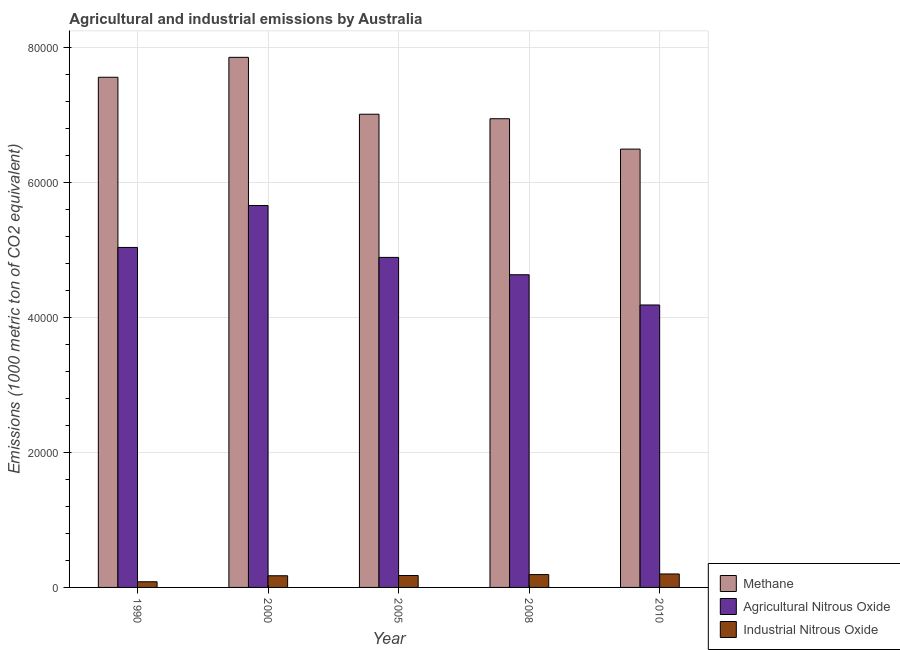How many groups of bars are there?
Ensure brevity in your answer.  5. What is the label of the 1st group of bars from the left?
Ensure brevity in your answer.  1990. What is the amount of methane emissions in 2000?
Make the answer very short. 7.85e+04. Across all years, what is the maximum amount of agricultural nitrous oxide emissions?
Provide a succinct answer. 5.66e+04. Across all years, what is the minimum amount of methane emissions?
Provide a short and direct response. 6.50e+04. What is the total amount of methane emissions in the graph?
Provide a short and direct response. 3.59e+05. What is the difference between the amount of methane emissions in 1990 and that in 2010?
Keep it short and to the point. 1.06e+04. What is the difference between the amount of industrial nitrous oxide emissions in 2005 and the amount of agricultural nitrous oxide emissions in 1990?
Ensure brevity in your answer.  925.7. What is the average amount of industrial nitrous oxide emissions per year?
Offer a very short reply. 1646.6. What is the ratio of the amount of industrial nitrous oxide emissions in 2005 to that in 2010?
Your response must be concise. 0.89. Is the difference between the amount of industrial nitrous oxide emissions in 2008 and 2010 greater than the difference between the amount of methane emissions in 2008 and 2010?
Offer a very short reply. No. What is the difference between the highest and the second highest amount of methane emissions?
Give a very brief answer. 2952.5. What is the difference between the highest and the lowest amount of industrial nitrous oxide emissions?
Offer a very short reply. 1155. In how many years, is the amount of methane emissions greater than the average amount of methane emissions taken over all years?
Ensure brevity in your answer.  2. Is the sum of the amount of industrial nitrous oxide emissions in 1990 and 2008 greater than the maximum amount of agricultural nitrous oxide emissions across all years?
Offer a terse response. Yes. What does the 2nd bar from the left in 2000 represents?
Provide a succinct answer. Agricultural Nitrous Oxide. What does the 2nd bar from the right in 2010 represents?
Your answer should be compact. Agricultural Nitrous Oxide. Is it the case that in every year, the sum of the amount of methane emissions and amount of agricultural nitrous oxide emissions is greater than the amount of industrial nitrous oxide emissions?
Provide a succinct answer. Yes. Are the values on the major ticks of Y-axis written in scientific E-notation?
Give a very brief answer. No. What is the title of the graph?
Your response must be concise. Agricultural and industrial emissions by Australia. Does "Poland" appear as one of the legend labels in the graph?
Provide a short and direct response. No. What is the label or title of the Y-axis?
Keep it short and to the point. Emissions (1000 metric ton of CO2 equivalent). What is the Emissions (1000 metric ton of CO2 equivalent) in Methane in 1990?
Your answer should be very brief. 7.56e+04. What is the Emissions (1000 metric ton of CO2 equivalent) of Agricultural Nitrous Oxide in 1990?
Make the answer very short. 5.04e+04. What is the Emissions (1000 metric ton of CO2 equivalent) of Industrial Nitrous Oxide in 1990?
Give a very brief answer. 839.8. What is the Emissions (1000 metric ton of CO2 equivalent) of Methane in 2000?
Ensure brevity in your answer.  7.85e+04. What is the Emissions (1000 metric ton of CO2 equivalent) in Agricultural Nitrous Oxide in 2000?
Offer a very short reply. 5.66e+04. What is the Emissions (1000 metric ton of CO2 equivalent) of Industrial Nitrous Oxide in 2000?
Your response must be concise. 1729.8. What is the Emissions (1000 metric ton of CO2 equivalent) in Methane in 2005?
Offer a terse response. 7.01e+04. What is the Emissions (1000 metric ton of CO2 equivalent) in Agricultural Nitrous Oxide in 2005?
Make the answer very short. 4.89e+04. What is the Emissions (1000 metric ton of CO2 equivalent) of Industrial Nitrous Oxide in 2005?
Offer a terse response. 1765.5. What is the Emissions (1000 metric ton of CO2 equivalent) of Methane in 2008?
Your response must be concise. 6.95e+04. What is the Emissions (1000 metric ton of CO2 equivalent) of Agricultural Nitrous Oxide in 2008?
Your response must be concise. 4.63e+04. What is the Emissions (1000 metric ton of CO2 equivalent) in Industrial Nitrous Oxide in 2008?
Keep it short and to the point. 1903.1. What is the Emissions (1000 metric ton of CO2 equivalent) of Methane in 2010?
Ensure brevity in your answer.  6.50e+04. What is the Emissions (1000 metric ton of CO2 equivalent) of Agricultural Nitrous Oxide in 2010?
Provide a succinct answer. 4.19e+04. What is the Emissions (1000 metric ton of CO2 equivalent) in Industrial Nitrous Oxide in 2010?
Give a very brief answer. 1994.8. Across all years, what is the maximum Emissions (1000 metric ton of CO2 equivalent) of Methane?
Keep it short and to the point. 7.85e+04. Across all years, what is the maximum Emissions (1000 metric ton of CO2 equivalent) in Agricultural Nitrous Oxide?
Provide a short and direct response. 5.66e+04. Across all years, what is the maximum Emissions (1000 metric ton of CO2 equivalent) of Industrial Nitrous Oxide?
Ensure brevity in your answer.  1994.8. Across all years, what is the minimum Emissions (1000 metric ton of CO2 equivalent) of Methane?
Give a very brief answer. 6.50e+04. Across all years, what is the minimum Emissions (1000 metric ton of CO2 equivalent) in Agricultural Nitrous Oxide?
Ensure brevity in your answer.  4.19e+04. Across all years, what is the minimum Emissions (1000 metric ton of CO2 equivalent) in Industrial Nitrous Oxide?
Ensure brevity in your answer.  839.8. What is the total Emissions (1000 metric ton of CO2 equivalent) in Methane in the graph?
Ensure brevity in your answer.  3.59e+05. What is the total Emissions (1000 metric ton of CO2 equivalent) of Agricultural Nitrous Oxide in the graph?
Make the answer very short. 2.44e+05. What is the total Emissions (1000 metric ton of CO2 equivalent) in Industrial Nitrous Oxide in the graph?
Keep it short and to the point. 8233. What is the difference between the Emissions (1000 metric ton of CO2 equivalent) in Methane in 1990 and that in 2000?
Offer a very short reply. -2952.5. What is the difference between the Emissions (1000 metric ton of CO2 equivalent) of Agricultural Nitrous Oxide in 1990 and that in 2000?
Provide a short and direct response. -6212.8. What is the difference between the Emissions (1000 metric ton of CO2 equivalent) in Industrial Nitrous Oxide in 1990 and that in 2000?
Offer a terse response. -890. What is the difference between the Emissions (1000 metric ton of CO2 equivalent) in Methane in 1990 and that in 2005?
Your answer should be very brief. 5478.7. What is the difference between the Emissions (1000 metric ton of CO2 equivalent) in Agricultural Nitrous Oxide in 1990 and that in 2005?
Provide a succinct answer. 1475.2. What is the difference between the Emissions (1000 metric ton of CO2 equivalent) in Industrial Nitrous Oxide in 1990 and that in 2005?
Your response must be concise. -925.7. What is the difference between the Emissions (1000 metric ton of CO2 equivalent) of Methane in 1990 and that in 2008?
Keep it short and to the point. 6145.3. What is the difference between the Emissions (1000 metric ton of CO2 equivalent) of Agricultural Nitrous Oxide in 1990 and that in 2008?
Offer a terse response. 4045.5. What is the difference between the Emissions (1000 metric ton of CO2 equivalent) of Industrial Nitrous Oxide in 1990 and that in 2008?
Offer a terse response. -1063.3. What is the difference between the Emissions (1000 metric ton of CO2 equivalent) in Methane in 1990 and that in 2010?
Your response must be concise. 1.06e+04. What is the difference between the Emissions (1000 metric ton of CO2 equivalent) of Agricultural Nitrous Oxide in 1990 and that in 2010?
Provide a short and direct response. 8525.4. What is the difference between the Emissions (1000 metric ton of CO2 equivalent) in Industrial Nitrous Oxide in 1990 and that in 2010?
Your answer should be very brief. -1155. What is the difference between the Emissions (1000 metric ton of CO2 equivalent) of Methane in 2000 and that in 2005?
Offer a terse response. 8431.2. What is the difference between the Emissions (1000 metric ton of CO2 equivalent) in Agricultural Nitrous Oxide in 2000 and that in 2005?
Offer a terse response. 7688. What is the difference between the Emissions (1000 metric ton of CO2 equivalent) of Industrial Nitrous Oxide in 2000 and that in 2005?
Your answer should be very brief. -35.7. What is the difference between the Emissions (1000 metric ton of CO2 equivalent) of Methane in 2000 and that in 2008?
Ensure brevity in your answer.  9097.8. What is the difference between the Emissions (1000 metric ton of CO2 equivalent) of Agricultural Nitrous Oxide in 2000 and that in 2008?
Ensure brevity in your answer.  1.03e+04. What is the difference between the Emissions (1000 metric ton of CO2 equivalent) of Industrial Nitrous Oxide in 2000 and that in 2008?
Provide a succinct answer. -173.3. What is the difference between the Emissions (1000 metric ton of CO2 equivalent) in Methane in 2000 and that in 2010?
Provide a short and direct response. 1.36e+04. What is the difference between the Emissions (1000 metric ton of CO2 equivalent) in Agricultural Nitrous Oxide in 2000 and that in 2010?
Your response must be concise. 1.47e+04. What is the difference between the Emissions (1000 metric ton of CO2 equivalent) in Industrial Nitrous Oxide in 2000 and that in 2010?
Your answer should be very brief. -265. What is the difference between the Emissions (1000 metric ton of CO2 equivalent) in Methane in 2005 and that in 2008?
Make the answer very short. 666.6. What is the difference between the Emissions (1000 metric ton of CO2 equivalent) of Agricultural Nitrous Oxide in 2005 and that in 2008?
Provide a short and direct response. 2570.3. What is the difference between the Emissions (1000 metric ton of CO2 equivalent) in Industrial Nitrous Oxide in 2005 and that in 2008?
Your answer should be compact. -137.6. What is the difference between the Emissions (1000 metric ton of CO2 equivalent) of Methane in 2005 and that in 2010?
Ensure brevity in your answer.  5168.4. What is the difference between the Emissions (1000 metric ton of CO2 equivalent) of Agricultural Nitrous Oxide in 2005 and that in 2010?
Give a very brief answer. 7050.2. What is the difference between the Emissions (1000 metric ton of CO2 equivalent) of Industrial Nitrous Oxide in 2005 and that in 2010?
Ensure brevity in your answer.  -229.3. What is the difference between the Emissions (1000 metric ton of CO2 equivalent) of Methane in 2008 and that in 2010?
Your response must be concise. 4501.8. What is the difference between the Emissions (1000 metric ton of CO2 equivalent) in Agricultural Nitrous Oxide in 2008 and that in 2010?
Your answer should be very brief. 4479.9. What is the difference between the Emissions (1000 metric ton of CO2 equivalent) in Industrial Nitrous Oxide in 2008 and that in 2010?
Provide a succinct answer. -91.7. What is the difference between the Emissions (1000 metric ton of CO2 equivalent) in Methane in 1990 and the Emissions (1000 metric ton of CO2 equivalent) in Agricultural Nitrous Oxide in 2000?
Your response must be concise. 1.90e+04. What is the difference between the Emissions (1000 metric ton of CO2 equivalent) in Methane in 1990 and the Emissions (1000 metric ton of CO2 equivalent) in Industrial Nitrous Oxide in 2000?
Offer a very short reply. 7.39e+04. What is the difference between the Emissions (1000 metric ton of CO2 equivalent) in Agricultural Nitrous Oxide in 1990 and the Emissions (1000 metric ton of CO2 equivalent) in Industrial Nitrous Oxide in 2000?
Offer a terse response. 4.86e+04. What is the difference between the Emissions (1000 metric ton of CO2 equivalent) in Methane in 1990 and the Emissions (1000 metric ton of CO2 equivalent) in Agricultural Nitrous Oxide in 2005?
Offer a terse response. 2.67e+04. What is the difference between the Emissions (1000 metric ton of CO2 equivalent) in Methane in 1990 and the Emissions (1000 metric ton of CO2 equivalent) in Industrial Nitrous Oxide in 2005?
Your answer should be very brief. 7.38e+04. What is the difference between the Emissions (1000 metric ton of CO2 equivalent) of Agricultural Nitrous Oxide in 1990 and the Emissions (1000 metric ton of CO2 equivalent) of Industrial Nitrous Oxide in 2005?
Provide a short and direct response. 4.86e+04. What is the difference between the Emissions (1000 metric ton of CO2 equivalent) of Methane in 1990 and the Emissions (1000 metric ton of CO2 equivalent) of Agricultural Nitrous Oxide in 2008?
Your answer should be compact. 2.93e+04. What is the difference between the Emissions (1000 metric ton of CO2 equivalent) of Methane in 1990 and the Emissions (1000 metric ton of CO2 equivalent) of Industrial Nitrous Oxide in 2008?
Provide a succinct answer. 7.37e+04. What is the difference between the Emissions (1000 metric ton of CO2 equivalent) of Agricultural Nitrous Oxide in 1990 and the Emissions (1000 metric ton of CO2 equivalent) of Industrial Nitrous Oxide in 2008?
Offer a terse response. 4.85e+04. What is the difference between the Emissions (1000 metric ton of CO2 equivalent) in Methane in 1990 and the Emissions (1000 metric ton of CO2 equivalent) in Agricultural Nitrous Oxide in 2010?
Offer a terse response. 3.37e+04. What is the difference between the Emissions (1000 metric ton of CO2 equivalent) of Methane in 1990 and the Emissions (1000 metric ton of CO2 equivalent) of Industrial Nitrous Oxide in 2010?
Make the answer very short. 7.36e+04. What is the difference between the Emissions (1000 metric ton of CO2 equivalent) of Agricultural Nitrous Oxide in 1990 and the Emissions (1000 metric ton of CO2 equivalent) of Industrial Nitrous Oxide in 2010?
Keep it short and to the point. 4.84e+04. What is the difference between the Emissions (1000 metric ton of CO2 equivalent) of Methane in 2000 and the Emissions (1000 metric ton of CO2 equivalent) of Agricultural Nitrous Oxide in 2005?
Your response must be concise. 2.96e+04. What is the difference between the Emissions (1000 metric ton of CO2 equivalent) in Methane in 2000 and the Emissions (1000 metric ton of CO2 equivalent) in Industrial Nitrous Oxide in 2005?
Your answer should be very brief. 7.68e+04. What is the difference between the Emissions (1000 metric ton of CO2 equivalent) in Agricultural Nitrous Oxide in 2000 and the Emissions (1000 metric ton of CO2 equivalent) in Industrial Nitrous Oxide in 2005?
Ensure brevity in your answer.  5.48e+04. What is the difference between the Emissions (1000 metric ton of CO2 equivalent) in Methane in 2000 and the Emissions (1000 metric ton of CO2 equivalent) in Agricultural Nitrous Oxide in 2008?
Ensure brevity in your answer.  3.22e+04. What is the difference between the Emissions (1000 metric ton of CO2 equivalent) in Methane in 2000 and the Emissions (1000 metric ton of CO2 equivalent) in Industrial Nitrous Oxide in 2008?
Your response must be concise. 7.66e+04. What is the difference between the Emissions (1000 metric ton of CO2 equivalent) of Agricultural Nitrous Oxide in 2000 and the Emissions (1000 metric ton of CO2 equivalent) of Industrial Nitrous Oxide in 2008?
Offer a terse response. 5.47e+04. What is the difference between the Emissions (1000 metric ton of CO2 equivalent) in Methane in 2000 and the Emissions (1000 metric ton of CO2 equivalent) in Agricultural Nitrous Oxide in 2010?
Your answer should be compact. 3.67e+04. What is the difference between the Emissions (1000 metric ton of CO2 equivalent) of Methane in 2000 and the Emissions (1000 metric ton of CO2 equivalent) of Industrial Nitrous Oxide in 2010?
Offer a very short reply. 7.66e+04. What is the difference between the Emissions (1000 metric ton of CO2 equivalent) of Agricultural Nitrous Oxide in 2000 and the Emissions (1000 metric ton of CO2 equivalent) of Industrial Nitrous Oxide in 2010?
Your response must be concise. 5.46e+04. What is the difference between the Emissions (1000 metric ton of CO2 equivalent) of Methane in 2005 and the Emissions (1000 metric ton of CO2 equivalent) of Agricultural Nitrous Oxide in 2008?
Make the answer very short. 2.38e+04. What is the difference between the Emissions (1000 metric ton of CO2 equivalent) of Methane in 2005 and the Emissions (1000 metric ton of CO2 equivalent) of Industrial Nitrous Oxide in 2008?
Your answer should be very brief. 6.82e+04. What is the difference between the Emissions (1000 metric ton of CO2 equivalent) of Agricultural Nitrous Oxide in 2005 and the Emissions (1000 metric ton of CO2 equivalent) of Industrial Nitrous Oxide in 2008?
Offer a terse response. 4.70e+04. What is the difference between the Emissions (1000 metric ton of CO2 equivalent) in Methane in 2005 and the Emissions (1000 metric ton of CO2 equivalent) in Agricultural Nitrous Oxide in 2010?
Offer a terse response. 2.83e+04. What is the difference between the Emissions (1000 metric ton of CO2 equivalent) of Methane in 2005 and the Emissions (1000 metric ton of CO2 equivalent) of Industrial Nitrous Oxide in 2010?
Your response must be concise. 6.81e+04. What is the difference between the Emissions (1000 metric ton of CO2 equivalent) of Agricultural Nitrous Oxide in 2005 and the Emissions (1000 metric ton of CO2 equivalent) of Industrial Nitrous Oxide in 2010?
Ensure brevity in your answer.  4.69e+04. What is the difference between the Emissions (1000 metric ton of CO2 equivalent) of Methane in 2008 and the Emissions (1000 metric ton of CO2 equivalent) of Agricultural Nitrous Oxide in 2010?
Make the answer very short. 2.76e+04. What is the difference between the Emissions (1000 metric ton of CO2 equivalent) of Methane in 2008 and the Emissions (1000 metric ton of CO2 equivalent) of Industrial Nitrous Oxide in 2010?
Make the answer very short. 6.75e+04. What is the difference between the Emissions (1000 metric ton of CO2 equivalent) in Agricultural Nitrous Oxide in 2008 and the Emissions (1000 metric ton of CO2 equivalent) in Industrial Nitrous Oxide in 2010?
Provide a short and direct response. 4.43e+04. What is the average Emissions (1000 metric ton of CO2 equivalent) in Methane per year?
Offer a terse response. 7.17e+04. What is the average Emissions (1000 metric ton of CO2 equivalent) in Agricultural Nitrous Oxide per year?
Make the answer very short. 4.88e+04. What is the average Emissions (1000 metric ton of CO2 equivalent) in Industrial Nitrous Oxide per year?
Your answer should be compact. 1646.6. In the year 1990, what is the difference between the Emissions (1000 metric ton of CO2 equivalent) of Methane and Emissions (1000 metric ton of CO2 equivalent) of Agricultural Nitrous Oxide?
Give a very brief answer. 2.52e+04. In the year 1990, what is the difference between the Emissions (1000 metric ton of CO2 equivalent) in Methane and Emissions (1000 metric ton of CO2 equivalent) in Industrial Nitrous Oxide?
Your response must be concise. 7.48e+04. In the year 1990, what is the difference between the Emissions (1000 metric ton of CO2 equivalent) in Agricultural Nitrous Oxide and Emissions (1000 metric ton of CO2 equivalent) in Industrial Nitrous Oxide?
Give a very brief answer. 4.95e+04. In the year 2000, what is the difference between the Emissions (1000 metric ton of CO2 equivalent) of Methane and Emissions (1000 metric ton of CO2 equivalent) of Agricultural Nitrous Oxide?
Your answer should be very brief. 2.20e+04. In the year 2000, what is the difference between the Emissions (1000 metric ton of CO2 equivalent) of Methane and Emissions (1000 metric ton of CO2 equivalent) of Industrial Nitrous Oxide?
Offer a terse response. 7.68e+04. In the year 2000, what is the difference between the Emissions (1000 metric ton of CO2 equivalent) of Agricultural Nitrous Oxide and Emissions (1000 metric ton of CO2 equivalent) of Industrial Nitrous Oxide?
Keep it short and to the point. 5.49e+04. In the year 2005, what is the difference between the Emissions (1000 metric ton of CO2 equivalent) of Methane and Emissions (1000 metric ton of CO2 equivalent) of Agricultural Nitrous Oxide?
Provide a succinct answer. 2.12e+04. In the year 2005, what is the difference between the Emissions (1000 metric ton of CO2 equivalent) of Methane and Emissions (1000 metric ton of CO2 equivalent) of Industrial Nitrous Oxide?
Your response must be concise. 6.84e+04. In the year 2005, what is the difference between the Emissions (1000 metric ton of CO2 equivalent) in Agricultural Nitrous Oxide and Emissions (1000 metric ton of CO2 equivalent) in Industrial Nitrous Oxide?
Give a very brief answer. 4.71e+04. In the year 2008, what is the difference between the Emissions (1000 metric ton of CO2 equivalent) in Methane and Emissions (1000 metric ton of CO2 equivalent) in Agricultural Nitrous Oxide?
Give a very brief answer. 2.31e+04. In the year 2008, what is the difference between the Emissions (1000 metric ton of CO2 equivalent) in Methane and Emissions (1000 metric ton of CO2 equivalent) in Industrial Nitrous Oxide?
Your answer should be compact. 6.75e+04. In the year 2008, what is the difference between the Emissions (1000 metric ton of CO2 equivalent) of Agricultural Nitrous Oxide and Emissions (1000 metric ton of CO2 equivalent) of Industrial Nitrous Oxide?
Provide a short and direct response. 4.44e+04. In the year 2010, what is the difference between the Emissions (1000 metric ton of CO2 equivalent) in Methane and Emissions (1000 metric ton of CO2 equivalent) in Agricultural Nitrous Oxide?
Provide a short and direct response. 2.31e+04. In the year 2010, what is the difference between the Emissions (1000 metric ton of CO2 equivalent) in Methane and Emissions (1000 metric ton of CO2 equivalent) in Industrial Nitrous Oxide?
Offer a very short reply. 6.30e+04. In the year 2010, what is the difference between the Emissions (1000 metric ton of CO2 equivalent) of Agricultural Nitrous Oxide and Emissions (1000 metric ton of CO2 equivalent) of Industrial Nitrous Oxide?
Keep it short and to the point. 3.99e+04. What is the ratio of the Emissions (1000 metric ton of CO2 equivalent) in Methane in 1990 to that in 2000?
Make the answer very short. 0.96. What is the ratio of the Emissions (1000 metric ton of CO2 equivalent) of Agricultural Nitrous Oxide in 1990 to that in 2000?
Ensure brevity in your answer.  0.89. What is the ratio of the Emissions (1000 metric ton of CO2 equivalent) in Industrial Nitrous Oxide in 1990 to that in 2000?
Your response must be concise. 0.49. What is the ratio of the Emissions (1000 metric ton of CO2 equivalent) of Methane in 1990 to that in 2005?
Your answer should be very brief. 1.08. What is the ratio of the Emissions (1000 metric ton of CO2 equivalent) of Agricultural Nitrous Oxide in 1990 to that in 2005?
Your answer should be compact. 1.03. What is the ratio of the Emissions (1000 metric ton of CO2 equivalent) of Industrial Nitrous Oxide in 1990 to that in 2005?
Your response must be concise. 0.48. What is the ratio of the Emissions (1000 metric ton of CO2 equivalent) of Methane in 1990 to that in 2008?
Offer a very short reply. 1.09. What is the ratio of the Emissions (1000 metric ton of CO2 equivalent) of Agricultural Nitrous Oxide in 1990 to that in 2008?
Provide a succinct answer. 1.09. What is the ratio of the Emissions (1000 metric ton of CO2 equivalent) of Industrial Nitrous Oxide in 1990 to that in 2008?
Give a very brief answer. 0.44. What is the ratio of the Emissions (1000 metric ton of CO2 equivalent) of Methane in 1990 to that in 2010?
Your answer should be very brief. 1.16. What is the ratio of the Emissions (1000 metric ton of CO2 equivalent) of Agricultural Nitrous Oxide in 1990 to that in 2010?
Offer a very short reply. 1.2. What is the ratio of the Emissions (1000 metric ton of CO2 equivalent) of Industrial Nitrous Oxide in 1990 to that in 2010?
Your response must be concise. 0.42. What is the ratio of the Emissions (1000 metric ton of CO2 equivalent) of Methane in 2000 to that in 2005?
Provide a succinct answer. 1.12. What is the ratio of the Emissions (1000 metric ton of CO2 equivalent) in Agricultural Nitrous Oxide in 2000 to that in 2005?
Provide a short and direct response. 1.16. What is the ratio of the Emissions (1000 metric ton of CO2 equivalent) of Industrial Nitrous Oxide in 2000 to that in 2005?
Offer a very short reply. 0.98. What is the ratio of the Emissions (1000 metric ton of CO2 equivalent) of Methane in 2000 to that in 2008?
Provide a short and direct response. 1.13. What is the ratio of the Emissions (1000 metric ton of CO2 equivalent) of Agricultural Nitrous Oxide in 2000 to that in 2008?
Offer a very short reply. 1.22. What is the ratio of the Emissions (1000 metric ton of CO2 equivalent) of Industrial Nitrous Oxide in 2000 to that in 2008?
Your answer should be compact. 0.91. What is the ratio of the Emissions (1000 metric ton of CO2 equivalent) in Methane in 2000 to that in 2010?
Your response must be concise. 1.21. What is the ratio of the Emissions (1000 metric ton of CO2 equivalent) in Agricultural Nitrous Oxide in 2000 to that in 2010?
Ensure brevity in your answer.  1.35. What is the ratio of the Emissions (1000 metric ton of CO2 equivalent) of Industrial Nitrous Oxide in 2000 to that in 2010?
Offer a terse response. 0.87. What is the ratio of the Emissions (1000 metric ton of CO2 equivalent) of Methane in 2005 to that in 2008?
Your response must be concise. 1.01. What is the ratio of the Emissions (1000 metric ton of CO2 equivalent) of Agricultural Nitrous Oxide in 2005 to that in 2008?
Provide a succinct answer. 1.06. What is the ratio of the Emissions (1000 metric ton of CO2 equivalent) in Industrial Nitrous Oxide in 2005 to that in 2008?
Offer a very short reply. 0.93. What is the ratio of the Emissions (1000 metric ton of CO2 equivalent) in Methane in 2005 to that in 2010?
Offer a terse response. 1.08. What is the ratio of the Emissions (1000 metric ton of CO2 equivalent) in Agricultural Nitrous Oxide in 2005 to that in 2010?
Your response must be concise. 1.17. What is the ratio of the Emissions (1000 metric ton of CO2 equivalent) in Industrial Nitrous Oxide in 2005 to that in 2010?
Provide a short and direct response. 0.89. What is the ratio of the Emissions (1000 metric ton of CO2 equivalent) in Methane in 2008 to that in 2010?
Keep it short and to the point. 1.07. What is the ratio of the Emissions (1000 metric ton of CO2 equivalent) of Agricultural Nitrous Oxide in 2008 to that in 2010?
Give a very brief answer. 1.11. What is the ratio of the Emissions (1000 metric ton of CO2 equivalent) in Industrial Nitrous Oxide in 2008 to that in 2010?
Give a very brief answer. 0.95. What is the difference between the highest and the second highest Emissions (1000 metric ton of CO2 equivalent) of Methane?
Offer a terse response. 2952.5. What is the difference between the highest and the second highest Emissions (1000 metric ton of CO2 equivalent) of Agricultural Nitrous Oxide?
Ensure brevity in your answer.  6212.8. What is the difference between the highest and the second highest Emissions (1000 metric ton of CO2 equivalent) of Industrial Nitrous Oxide?
Ensure brevity in your answer.  91.7. What is the difference between the highest and the lowest Emissions (1000 metric ton of CO2 equivalent) of Methane?
Give a very brief answer. 1.36e+04. What is the difference between the highest and the lowest Emissions (1000 metric ton of CO2 equivalent) in Agricultural Nitrous Oxide?
Your answer should be compact. 1.47e+04. What is the difference between the highest and the lowest Emissions (1000 metric ton of CO2 equivalent) of Industrial Nitrous Oxide?
Give a very brief answer. 1155. 